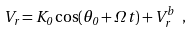Convert formula to latex. <formula><loc_0><loc_0><loc_500><loc_500>V _ { r } = K _ { 0 } \cos ( \theta _ { 0 } + \Omega \, t ) + V _ { r } ^ { b } \ ,</formula> 